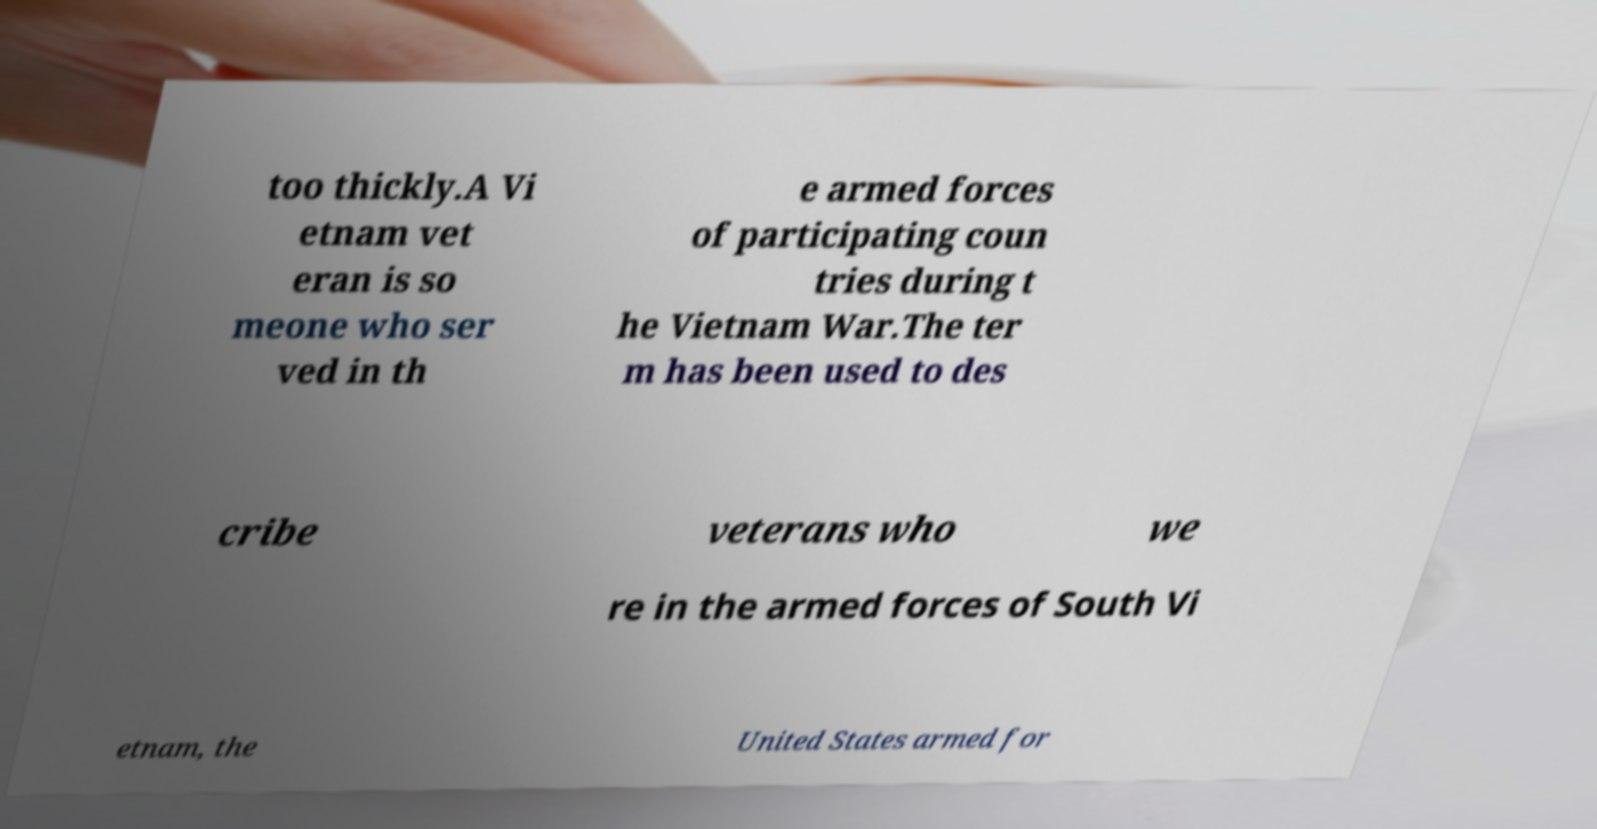Could you extract and type out the text from this image? too thickly.A Vi etnam vet eran is so meone who ser ved in th e armed forces of participating coun tries during t he Vietnam War.The ter m has been used to des cribe veterans who we re in the armed forces of South Vi etnam, the United States armed for 